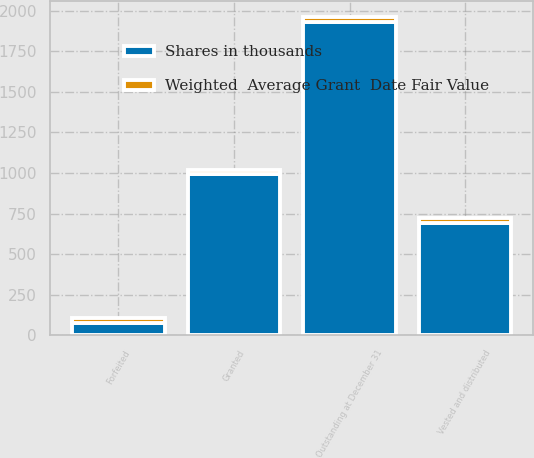Convert chart. <chart><loc_0><loc_0><loc_500><loc_500><stacked_bar_chart><ecel><fcel>Outstanding at December 31<fcel>Granted<fcel>Vested and distributed<fcel>Forfeited<nl><fcel>Shares in thousands<fcel>1930<fcel>992<fcel>691<fcel>77<nl><fcel>Weighted  Average Grant  Date Fair Value<fcel>30.92<fcel>28.97<fcel>30.46<fcel>30.51<nl></chart> 